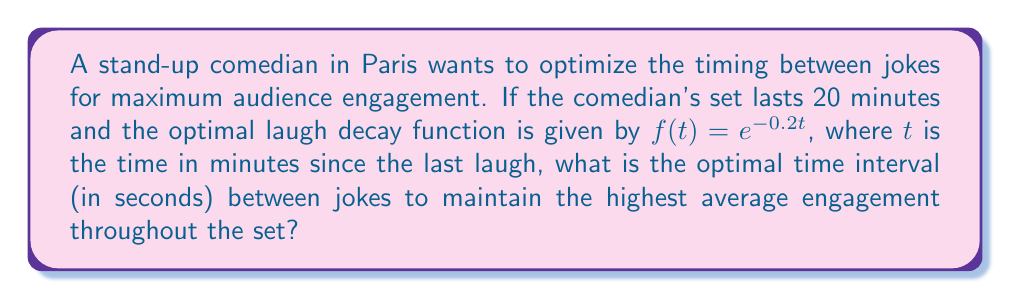Can you answer this question? Let's approach this step-by-step:

1) The laugh decay function is given by $f(t) = e^{-0.2t}$, where $t$ is in minutes.

2) To find the optimal interval, we need to maximize the average value of this function over the interval.

3) The average value of a function over an interval $[0,T]$ is given by:

   $$\frac{1}{T} \int_0^T f(t) dt$$

4) In our case, this becomes:

   $$\frac{1}{T} \int_0^T e^{-0.2t} dt$$

5) Solving this integral:

   $$\frac{1}{T} [-5e^{-0.2t}]_0^T = \frac{1}{T} [(-5e^{-0.2T}) - (-5)] = \frac{5}{T}(1 - e^{-0.2T})$$

6) To find the maximum, we differentiate with respect to $T$ and set to zero:

   $$\frac{d}{dT}[\frac{5}{T}(1 - e^{-0.2T})] = \frac{5}{T^2}(-1 + e^{-0.2T} + 0.2Te^{-0.2T}) = 0$$

7) Solving this equation numerically (as it can't be solved algebraically) gives:

   $$T \approx 5 \text{ minutes}$$

8) Converting to seconds:

   $$5 \text{ minutes} \times 60 \text{ seconds/minute} = 300 \text{ seconds}$$

Therefore, the optimal time between jokes is approximately 300 seconds.
Answer: 300 seconds 